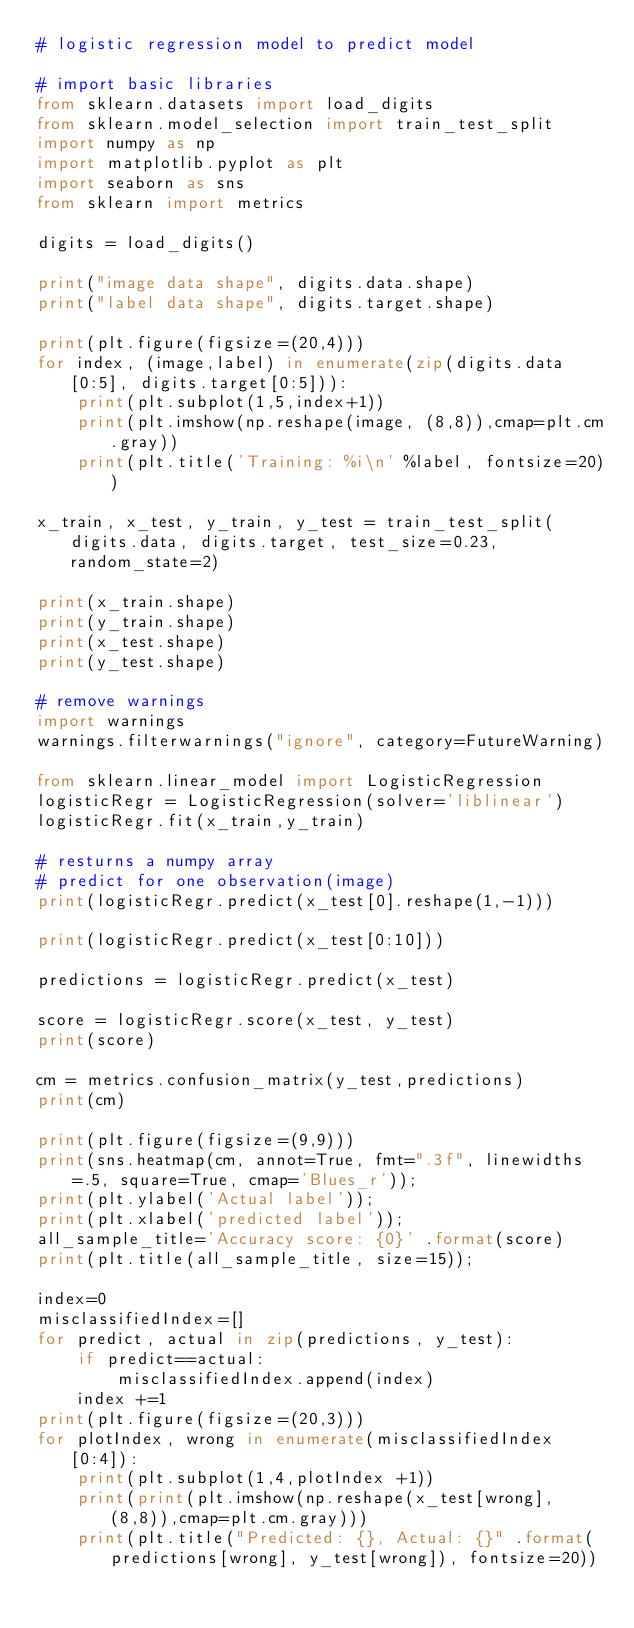Convert code to text. <code><loc_0><loc_0><loc_500><loc_500><_Python_># logistic regression model to predict model

# import basic libraries
from sklearn.datasets import load_digits
from sklearn.model_selection import train_test_split
import numpy as np
import matplotlib.pyplot as plt
import seaborn as sns
from sklearn import metrics

digits = load_digits()

print("image data shape", digits.data.shape)
print("label data shape", digits.target.shape)

print(plt.figure(figsize=(20,4)))
for index, (image,label) in enumerate(zip(digits.data[0:5], digits.target[0:5])):
    print(plt.subplot(1,5,index+1))
    print(plt.imshow(np.reshape(image, (8,8)),cmap=plt.cm.gray))
    print(plt.title('Training: %i\n' %label, fontsize=20))

x_train, x_test, y_train, y_test = train_test_split(digits.data, digits.target, test_size=0.23, random_state=2)

print(x_train.shape)
print(y_train.shape)
print(x_test.shape)
print(y_test.shape)

# remove warnings
import warnings
warnings.filterwarnings("ignore", category=FutureWarning)

from sklearn.linear_model import LogisticRegression
logisticRegr = LogisticRegression(solver='liblinear')
logisticRegr.fit(x_train,y_train)

# resturns a numpy array
# predict for one observation(image)
print(logisticRegr.predict(x_test[0].reshape(1,-1)))

print(logisticRegr.predict(x_test[0:10]))

predictions = logisticRegr.predict(x_test)

score = logisticRegr.score(x_test, y_test)
print(score)

cm = metrics.confusion_matrix(y_test,predictions)
print(cm)

print(plt.figure(figsize=(9,9)))
print(sns.heatmap(cm, annot=True, fmt=".3f", linewidths=.5, square=True, cmap='Blues_r'));
print(plt.ylabel('Actual label'));
print(plt.xlabel('predicted label'));
all_sample_title='Accuracy score: {0}' .format(score)
print(plt.title(all_sample_title, size=15));

index=0
misclassifiedIndex=[]
for predict, actual in zip(predictions, y_test):
    if predict==actual:
        misclassifiedIndex.append(index)
    index +=1
print(plt.figure(figsize=(20,3)))
for plotIndex, wrong in enumerate(misclassifiedIndex[0:4]):
    print(plt.subplot(1,4,plotIndex +1))
    print(print(plt.imshow(np.reshape(x_test[wrong], (8,8)),cmap=plt.cm.gray)))
    print(plt.title("Predicted: {}, Actual: {}" .format(predictions[wrong], y_test[wrong]), fontsize=20))
</code> 